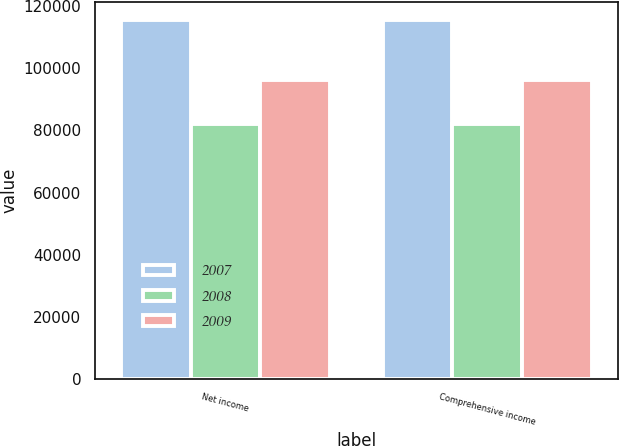Convert chart to OTSL. <chart><loc_0><loc_0><loc_500><loc_500><stacked_bar_chart><ecel><fcel>Net income<fcel>Comprehensive income<nl><fcel>2007<fcel>115466<fcel>115466<nl><fcel>2008<fcel>81930<fcel>81930<nl><fcel>2009<fcel>96241<fcel>96263<nl></chart> 